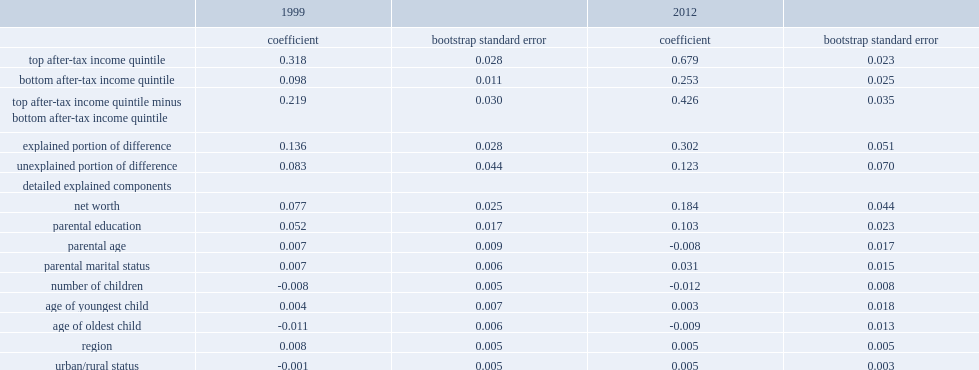Overall, what proportion of the 21.9 percentage point difference could be explained by differences in socioeconomic characteristics in 1999? 0.136. How much did differences in net worth (less resps) accounted for of the overall difference in the resp participation rate between families in the top and bottom income quintiles in 1999? 0.077. What was the proportion of differences in net worth (less resps) of the overall difference in the resp participation rate between families in the top and bottom income quintiles in 1999? 0.351598. How much did differences in parental education accounted for of the overall difference in the resp participation rate between families in the top and bottom income quintiles in 1999? 0.052. What was the proportion of differences in parental education of the overall difference in the resp participation rate between families in the top and bottom income quintiles in 1999? 0.237443. How many times was the gap in resp participation between families in the top and bottom income quintiles in 2012 than that in 1999? 1.945205. Overall, how much of the 42.6 percentage points could be explained by differences in socioeconomic characteristicins 2012? 0.302. Overall, what proportion of the 42.6 percentage points could be explained by differences in socioeconomic characteristicins 2012? 0.70892. How much did differences in net worth (less resps) account for of the overall difference in resp participation rates across income quintiles in 2012? 0.431925. How much did differences in parental education account for of the overall difference in resp participation rates across income quintiles in 2012? 0.241784. How much did differences in marital status account for of the overall difference in resp participation rates across income quintiles in 2012? 0.07277. 